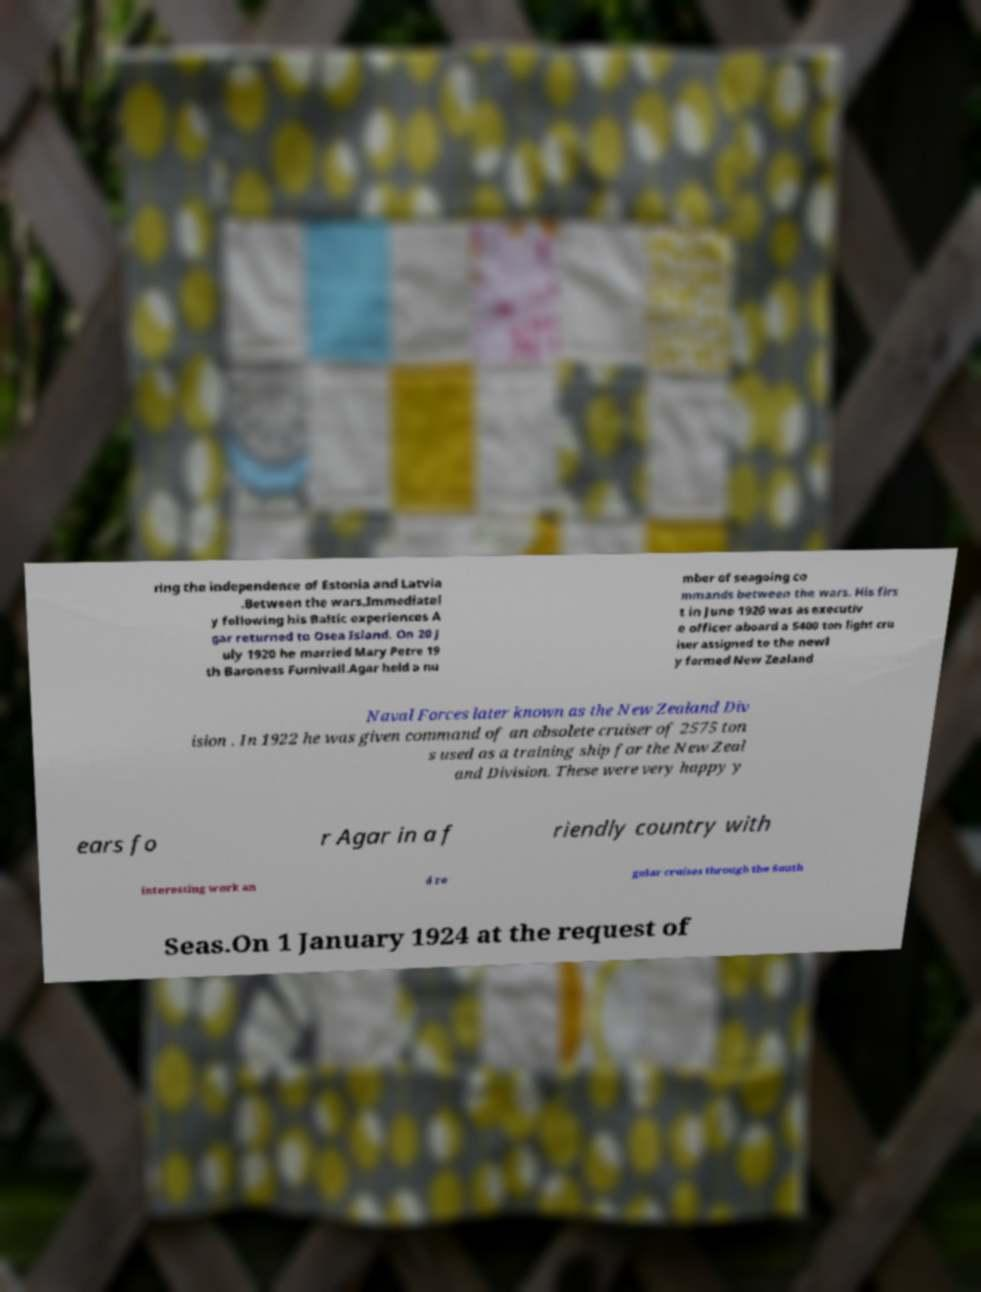There's text embedded in this image that I need extracted. Can you transcribe it verbatim? ring the independence of Estonia and Latvia .Between the wars.Immediatel y following his Baltic experiences A gar returned to Osea Island. On 20 J uly 1920 he married Mary Petre 19 th Baroness Furnivall.Agar held a nu mber of seagoing co mmands between the wars. His firs t in June 1920 was as executiv e officer aboard a 5400 ton light cru iser assigned to the newl y formed New Zealand Naval Forces later known as the New Zealand Div ision . In 1922 he was given command of an obsolete cruiser of 2575 ton s used as a training ship for the New Zeal and Division. These were very happy y ears fo r Agar in a f riendly country with interesting work an d re gular cruises through the South Seas.On 1 January 1924 at the request of 